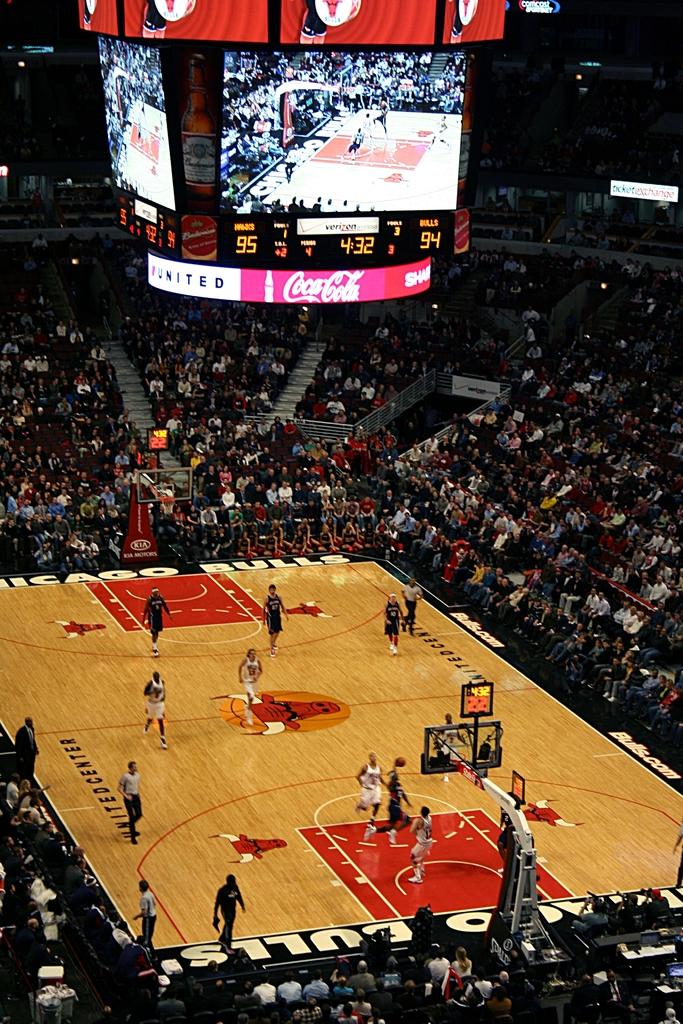What soda brand is advertising at this arena?
Keep it short and to the point. Coca cola. How many points do the bulls have?
Give a very brief answer. 94. 